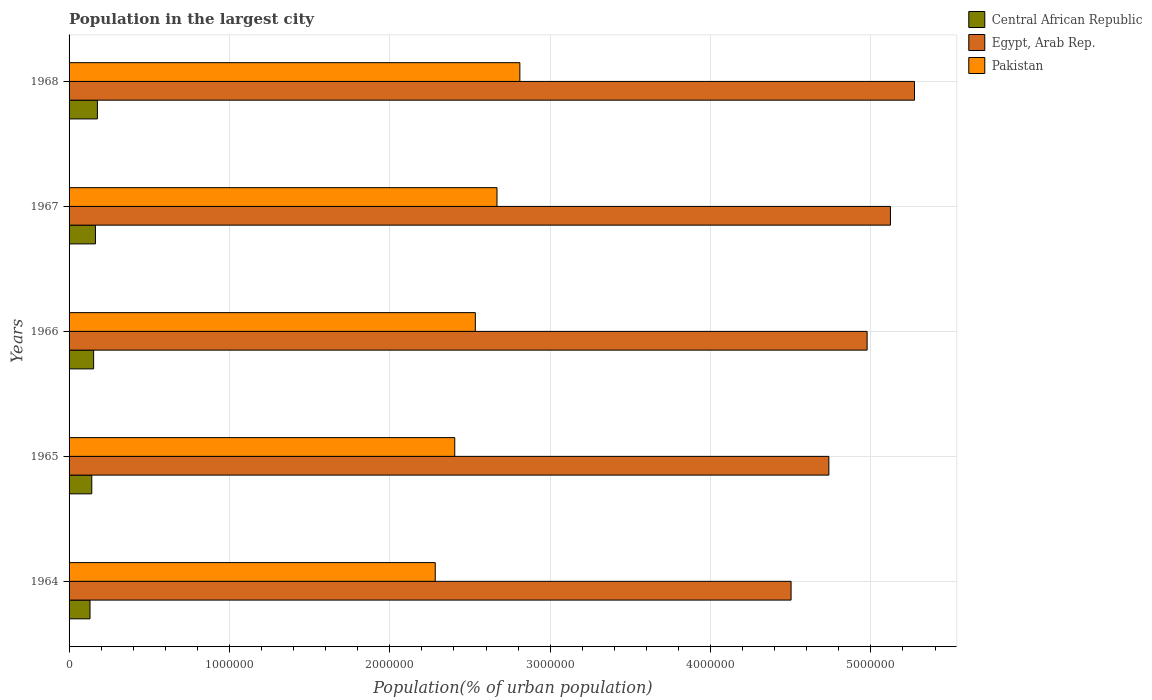How many different coloured bars are there?
Your answer should be compact. 3. Are the number of bars per tick equal to the number of legend labels?
Provide a short and direct response. Yes. How many bars are there on the 5th tick from the top?
Make the answer very short. 3. What is the label of the 3rd group of bars from the top?
Your response must be concise. 1966. What is the population in the largest city in Egypt, Arab Rep. in 1968?
Offer a terse response. 5.27e+06. Across all years, what is the maximum population in the largest city in Egypt, Arab Rep.?
Offer a very short reply. 5.27e+06. Across all years, what is the minimum population in the largest city in Central African Republic?
Offer a very short reply. 1.31e+05. In which year was the population in the largest city in Pakistan maximum?
Offer a terse response. 1968. In which year was the population in the largest city in Central African Republic minimum?
Give a very brief answer. 1964. What is the total population in the largest city in Pakistan in the graph?
Your answer should be very brief. 1.27e+07. What is the difference between the population in the largest city in Central African Republic in 1964 and that in 1965?
Offer a very short reply. -1.10e+04. What is the difference between the population in the largest city in Central African Republic in 1966 and the population in the largest city in Egypt, Arab Rep. in 1968?
Give a very brief answer. -5.12e+06. What is the average population in the largest city in Egypt, Arab Rep. per year?
Give a very brief answer. 4.92e+06. In the year 1967, what is the difference between the population in the largest city in Pakistan and population in the largest city in Egypt, Arab Rep.?
Keep it short and to the point. -2.45e+06. In how many years, is the population in the largest city in Central African Republic greater than 1200000 %?
Keep it short and to the point. 0. What is the ratio of the population in the largest city in Pakistan in 1966 to that in 1967?
Your answer should be compact. 0.95. Is the population in the largest city in Pakistan in 1966 less than that in 1967?
Keep it short and to the point. Yes. What is the difference between the highest and the second highest population in the largest city in Pakistan?
Keep it short and to the point. 1.43e+05. What is the difference between the highest and the lowest population in the largest city in Pakistan?
Ensure brevity in your answer.  5.28e+05. Is the sum of the population in the largest city in Pakistan in 1964 and 1966 greater than the maximum population in the largest city in Central African Republic across all years?
Keep it short and to the point. Yes. What does the 2nd bar from the top in 1964 represents?
Your answer should be compact. Egypt, Arab Rep. What does the 2nd bar from the bottom in 1966 represents?
Give a very brief answer. Egypt, Arab Rep. How many bars are there?
Offer a terse response. 15. Are all the bars in the graph horizontal?
Provide a short and direct response. Yes. What is the difference between two consecutive major ticks on the X-axis?
Make the answer very short. 1.00e+06. Are the values on the major ticks of X-axis written in scientific E-notation?
Offer a terse response. No. Does the graph contain any zero values?
Offer a very short reply. No. Where does the legend appear in the graph?
Make the answer very short. Top right. How many legend labels are there?
Keep it short and to the point. 3. What is the title of the graph?
Give a very brief answer. Population in the largest city. What is the label or title of the X-axis?
Make the answer very short. Population(% of urban population). What is the Population(% of urban population) in Central African Republic in 1964?
Provide a succinct answer. 1.31e+05. What is the Population(% of urban population) of Egypt, Arab Rep. in 1964?
Ensure brevity in your answer.  4.50e+06. What is the Population(% of urban population) in Pakistan in 1964?
Give a very brief answer. 2.28e+06. What is the Population(% of urban population) of Central African Republic in 1965?
Your answer should be very brief. 1.42e+05. What is the Population(% of urban population) in Egypt, Arab Rep. in 1965?
Ensure brevity in your answer.  4.74e+06. What is the Population(% of urban population) of Pakistan in 1965?
Your response must be concise. 2.41e+06. What is the Population(% of urban population) in Central African Republic in 1966?
Your answer should be compact. 1.53e+05. What is the Population(% of urban population) in Egypt, Arab Rep. in 1966?
Keep it short and to the point. 4.98e+06. What is the Population(% of urban population) in Pakistan in 1966?
Provide a short and direct response. 2.53e+06. What is the Population(% of urban population) of Central African Republic in 1967?
Give a very brief answer. 1.65e+05. What is the Population(% of urban population) of Egypt, Arab Rep. in 1967?
Make the answer very short. 5.12e+06. What is the Population(% of urban population) in Pakistan in 1967?
Provide a short and direct response. 2.67e+06. What is the Population(% of urban population) in Central African Republic in 1968?
Offer a terse response. 1.77e+05. What is the Population(% of urban population) of Egypt, Arab Rep. in 1968?
Make the answer very short. 5.27e+06. What is the Population(% of urban population) of Pakistan in 1968?
Your response must be concise. 2.81e+06. Across all years, what is the maximum Population(% of urban population) of Central African Republic?
Your answer should be compact. 1.77e+05. Across all years, what is the maximum Population(% of urban population) in Egypt, Arab Rep.?
Provide a succinct answer. 5.27e+06. Across all years, what is the maximum Population(% of urban population) of Pakistan?
Give a very brief answer. 2.81e+06. Across all years, what is the minimum Population(% of urban population) in Central African Republic?
Your answer should be compact. 1.31e+05. Across all years, what is the minimum Population(% of urban population) in Egypt, Arab Rep.?
Make the answer very short. 4.50e+06. Across all years, what is the minimum Population(% of urban population) in Pakistan?
Ensure brevity in your answer.  2.28e+06. What is the total Population(% of urban population) in Central African Republic in the graph?
Offer a very short reply. 7.67e+05. What is the total Population(% of urban population) of Egypt, Arab Rep. in the graph?
Keep it short and to the point. 2.46e+07. What is the total Population(% of urban population) of Pakistan in the graph?
Ensure brevity in your answer.  1.27e+07. What is the difference between the Population(% of urban population) of Central African Republic in 1964 and that in 1965?
Your answer should be compact. -1.10e+04. What is the difference between the Population(% of urban population) in Egypt, Arab Rep. in 1964 and that in 1965?
Your answer should be compact. -2.36e+05. What is the difference between the Population(% of urban population) of Pakistan in 1964 and that in 1965?
Your answer should be compact. -1.22e+05. What is the difference between the Population(% of urban population) in Central African Republic in 1964 and that in 1966?
Make the answer very short. -2.26e+04. What is the difference between the Population(% of urban population) of Egypt, Arab Rep. in 1964 and that in 1966?
Your answer should be compact. -4.74e+05. What is the difference between the Population(% of urban population) of Pakistan in 1964 and that in 1966?
Ensure brevity in your answer.  -2.50e+05. What is the difference between the Population(% of urban population) in Central African Republic in 1964 and that in 1967?
Your answer should be compact. -3.39e+04. What is the difference between the Population(% of urban population) of Egypt, Arab Rep. in 1964 and that in 1967?
Your answer should be very brief. -6.20e+05. What is the difference between the Population(% of urban population) of Pakistan in 1964 and that in 1967?
Give a very brief answer. -3.85e+05. What is the difference between the Population(% of urban population) of Central African Republic in 1964 and that in 1968?
Offer a very short reply. -4.61e+04. What is the difference between the Population(% of urban population) in Egypt, Arab Rep. in 1964 and that in 1968?
Provide a short and direct response. -7.70e+05. What is the difference between the Population(% of urban population) of Pakistan in 1964 and that in 1968?
Ensure brevity in your answer.  -5.28e+05. What is the difference between the Population(% of urban population) of Central African Republic in 1965 and that in 1966?
Offer a very short reply. -1.15e+04. What is the difference between the Population(% of urban population) of Egypt, Arab Rep. in 1965 and that in 1966?
Offer a terse response. -2.39e+05. What is the difference between the Population(% of urban population) of Pakistan in 1965 and that in 1966?
Your answer should be very brief. -1.28e+05. What is the difference between the Population(% of urban population) of Central African Republic in 1965 and that in 1967?
Offer a terse response. -2.29e+04. What is the difference between the Population(% of urban population) in Egypt, Arab Rep. in 1965 and that in 1967?
Provide a short and direct response. -3.84e+05. What is the difference between the Population(% of urban population) of Pakistan in 1965 and that in 1967?
Your answer should be very brief. -2.63e+05. What is the difference between the Population(% of urban population) of Central African Republic in 1965 and that in 1968?
Your response must be concise. -3.50e+04. What is the difference between the Population(% of urban population) in Egypt, Arab Rep. in 1965 and that in 1968?
Offer a very short reply. -5.34e+05. What is the difference between the Population(% of urban population) in Pakistan in 1965 and that in 1968?
Keep it short and to the point. -4.06e+05. What is the difference between the Population(% of urban population) in Central African Republic in 1966 and that in 1967?
Provide a short and direct response. -1.13e+04. What is the difference between the Population(% of urban population) of Egypt, Arab Rep. in 1966 and that in 1967?
Your answer should be compact. -1.45e+05. What is the difference between the Population(% of urban population) of Pakistan in 1966 and that in 1967?
Keep it short and to the point. -1.35e+05. What is the difference between the Population(% of urban population) in Central African Republic in 1966 and that in 1968?
Ensure brevity in your answer.  -2.35e+04. What is the difference between the Population(% of urban population) of Egypt, Arab Rep. in 1966 and that in 1968?
Your answer should be very brief. -2.95e+05. What is the difference between the Population(% of urban population) in Pakistan in 1966 and that in 1968?
Keep it short and to the point. -2.78e+05. What is the difference between the Population(% of urban population) in Central African Republic in 1967 and that in 1968?
Give a very brief answer. -1.22e+04. What is the difference between the Population(% of urban population) of Egypt, Arab Rep. in 1967 and that in 1968?
Ensure brevity in your answer.  -1.50e+05. What is the difference between the Population(% of urban population) in Pakistan in 1967 and that in 1968?
Give a very brief answer. -1.43e+05. What is the difference between the Population(% of urban population) of Central African Republic in 1964 and the Population(% of urban population) of Egypt, Arab Rep. in 1965?
Keep it short and to the point. -4.61e+06. What is the difference between the Population(% of urban population) of Central African Republic in 1964 and the Population(% of urban population) of Pakistan in 1965?
Offer a very short reply. -2.27e+06. What is the difference between the Population(% of urban population) in Egypt, Arab Rep. in 1964 and the Population(% of urban population) in Pakistan in 1965?
Offer a terse response. 2.10e+06. What is the difference between the Population(% of urban population) of Central African Republic in 1964 and the Population(% of urban population) of Egypt, Arab Rep. in 1966?
Provide a succinct answer. -4.85e+06. What is the difference between the Population(% of urban population) in Central African Republic in 1964 and the Population(% of urban population) in Pakistan in 1966?
Your response must be concise. -2.40e+06. What is the difference between the Population(% of urban population) in Egypt, Arab Rep. in 1964 and the Population(% of urban population) in Pakistan in 1966?
Provide a succinct answer. 1.97e+06. What is the difference between the Population(% of urban population) of Central African Republic in 1964 and the Population(% of urban population) of Egypt, Arab Rep. in 1967?
Your response must be concise. -4.99e+06. What is the difference between the Population(% of urban population) in Central African Republic in 1964 and the Population(% of urban population) in Pakistan in 1967?
Keep it short and to the point. -2.54e+06. What is the difference between the Population(% of urban population) of Egypt, Arab Rep. in 1964 and the Population(% of urban population) of Pakistan in 1967?
Give a very brief answer. 1.83e+06. What is the difference between the Population(% of urban population) in Central African Republic in 1964 and the Population(% of urban population) in Egypt, Arab Rep. in 1968?
Keep it short and to the point. -5.14e+06. What is the difference between the Population(% of urban population) in Central African Republic in 1964 and the Population(% of urban population) in Pakistan in 1968?
Offer a terse response. -2.68e+06. What is the difference between the Population(% of urban population) of Egypt, Arab Rep. in 1964 and the Population(% of urban population) of Pakistan in 1968?
Your answer should be compact. 1.69e+06. What is the difference between the Population(% of urban population) in Central African Republic in 1965 and the Population(% of urban population) in Egypt, Arab Rep. in 1966?
Make the answer very short. -4.83e+06. What is the difference between the Population(% of urban population) in Central African Republic in 1965 and the Population(% of urban population) in Pakistan in 1966?
Your answer should be compact. -2.39e+06. What is the difference between the Population(% of urban population) in Egypt, Arab Rep. in 1965 and the Population(% of urban population) in Pakistan in 1966?
Offer a very short reply. 2.20e+06. What is the difference between the Population(% of urban population) of Central African Republic in 1965 and the Population(% of urban population) of Egypt, Arab Rep. in 1967?
Your response must be concise. -4.98e+06. What is the difference between the Population(% of urban population) in Central African Republic in 1965 and the Population(% of urban population) in Pakistan in 1967?
Keep it short and to the point. -2.53e+06. What is the difference between the Population(% of urban population) in Egypt, Arab Rep. in 1965 and the Population(% of urban population) in Pakistan in 1967?
Offer a terse response. 2.07e+06. What is the difference between the Population(% of urban population) of Central African Republic in 1965 and the Population(% of urban population) of Egypt, Arab Rep. in 1968?
Provide a succinct answer. -5.13e+06. What is the difference between the Population(% of urban population) in Central African Republic in 1965 and the Population(% of urban population) in Pakistan in 1968?
Make the answer very short. -2.67e+06. What is the difference between the Population(% of urban population) in Egypt, Arab Rep. in 1965 and the Population(% of urban population) in Pakistan in 1968?
Your answer should be compact. 1.93e+06. What is the difference between the Population(% of urban population) in Central African Republic in 1966 and the Population(% of urban population) in Egypt, Arab Rep. in 1967?
Your response must be concise. -4.97e+06. What is the difference between the Population(% of urban population) of Central African Republic in 1966 and the Population(% of urban population) of Pakistan in 1967?
Provide a succinct answer. -2.52e+06. What is the difference between the Population(% of urban population) of Egypt, Arab Rep. in 1966 and the Population(% of urban population) of Pakistan in 1967?
Make the answer very short. 2.31e+06. What is the difference between the Population(% of urban population) of Central African Republic in 1966 and the Population(% of urban population) of Egypt, Arab Rep. in 1968?
Your answer should be compact. -5.12e+06. What is the difference between the Population(% of urban population) in Central African Republic in 1966 and the Population(% of urban population) in Pakistan in 1968?
Offer a very short reply. -2.66e+06. What is the difference between the Population(% of urban population) in Egypt, Arab Rep. in 1966 and the Population(% of urban population) in Pakistan in 1968?
Keep it short and to the point. 2.17e+06. What is the difference between the Population(% of urban population) of Central African Republic in 1967 and the Population(% of urban population) of Egypt, Arab Rep. in 1968?
Make the answer very short. -5.11e+06. What is the difference between the Population(% of urban population) in Central African Republic in 1967 and the Population(% of urban population) in Pakistan in 1968?
Provide a succinct answer. -2.65e+06. What is the difference between the Population(% of urban population) of Egypt, Arab Rep. in 1967 and the Population(% of urban population) of Pakistan in 1968?
Provide a succinct answer. 2.31e+06. What is the average Population(% of urban population) of Central African Republic per year?
Make the answer very short. 1.53e+05. What is the average Population(% of urban population) in Egypt, Arab Rep. per year?
Give a very brief answer. 4.92e+06. What is the average Population(% of urban population) of Pakistan per year?
Your answer should be compact. 2.54e+06. In the year 1964, what is the difference between the Population(% of urban population) of Central African Republic and Population(% of urban population) of Egypt, Arab Rep.?
Give a very brief answer. -4.37e+06. In the year 1964, what is the difference between the Population(% of urban population) of Central African Republic and Population(% of urban population) of Pakistan?
Ensure brevity in your answer.  -2.15e+06. In the year 1964, what is the difference between the Population(% of urban population) in Egypt, Arab Rep. and Population(% of urban population) in Pakistan?
Your response must be concise. 2.22e+06. In the year 1965, what is the difference between the Population(% of urban population) of Central African Republic and Population(% of urban population) of Egypt, Arab Rep.?
Offer a terse response. -4.60e+06. In the year 1965, what is the difference between the Population(% of urban population) in Central African Republic and Population(% of urban population) in Pakistan?
Offer a very short reply. -2.26e+06. In the year 1965, what is the difference between the Population(% of urban population) of Egypt, Arab Rep. and Population(% of urban population) of Pakistan?
Your answer should be compact. 2.33e+06. In the year 1966, what is the difference between the Population(% of urban population) of Central African Republic and Population(% of urban population) of Egypt, Arab Rep.?
Your answer should be compact. -4.82e+06. In the year 1966, what is the difference between the Population(% of urban population) in Central African Republic and Population(% of urban population) in Pakistan?
Give a very brief answer. -2.38e+06. In the year 1966, what is the difference between the Population(% of urban population) of Egypt, Arab Rep. and Population(% of urban population) of Pakistan?
Offer a very short reply. 2.44e+06. In the year 1967, what is the difference between the Population(% of urban population) in Central African Republic and Population(% of urban population) in Egypt, Arab Rep.?
Provide a short and direct response. -4.96e+06. In the year 1967, what is the difference between the Population(% of urban population) in Central African Republic and Population(% of urban population) in Pakistan?
Your answer should be compact. -2.50e+06. In the year 1967, what is the difference between the Population(% of urban population) in Egypt, Arab Rep. and Population(% of urban population) in Pakistan?
Your response must be concise. 2.45e+06. In the year 1968, what is the difference between the Population(% of urban population) in Central African Republic and Population(% of urban population) in Egypt, Arab Rep.?
Offer a terse response. -5.10e+06. In the year 1968, what is the difference between the Population(% of urban population) in Central African Republic and Population(% of urban population) in Pakistan?
Give a very brief answer. -2.63e+06. In the year 1968, what is the difference between the Population(% of urban population) of Egypt, Arab Rep. and Population(% of urban population) of Pakistan?
Your answer should be compact. 2.46e+06. What is the ratio of the Population(% of urban population) in Central African Republic in 1964 to that in 1965?
Offer a very short reply. 0.92. What is the ratio of the Population(% of urban population) of Egypt, Arab Rep. in 1964 to that in 1965?
Provide a succinct answer. 0.95. What is the ratio of the Population(% of urban population) in Pakistan in 1964 to that in 1965?
Your response must be concise. 0.95. What is the ratio of the Population(% of urban population) in Central African Republic in 1964 to that in 1966?
Give a very brief answer. 0.85. What is the ratio of the Population(% of urban population) of Egypt, Arab Rep. in 1964 to that in 1966?
Your response must be concise. 0.9. What is the ratio of the Population(% of urban population) in Pakistan in 1964 to that in 1966?
Ensure brevity in your answer.  0.9. What is the ratio of the Population(% of urban population) of Central African Republic in 1964 to that in 1967?
Give a very brief answer. 0.79. What is the ratio of the Population(% of urban population) in Egypt, Arab Rep. in 1964 to that in 1967?
Provide a succinct answer. 0.88. What is the ratio of the Population(% of urban population) of Pakistan in 1964 to that in 1967?
Provide a succinct answer. 0.86. What is the ratio of the Population(% of urban population) in Central African Republic in 1964 to that in 1968?
Provide a succinct answer. 0.74. What is the ratio of the Population(% of urban population) of Egypt, Arab Rep. in 1964 to that in 1968?
Keep it short and to the point. 0.85. What is the ratio of the Population(% of urban population) of Pakistan in 1964 to that in 1968?
Your response must be concise. 0.81. What is the ratio of the Population(% of urban population) in Central African Republic in 1965 to that in 1966?
Your response must be concise. 0.92. What is the ratio of the Population(% of urban population) in Egypt, Arab Rep. in 1965 to that in 1966?
Provide a succinct answer. 0.95. What is the ratio of the Population(% of urban population) of Pakistan in 1965 to that in 1966?
Offer a terse response. 0.95. What is the ratio of the Population(% of urban population) in Central African Republic in 1965 to that in 1967?
Your answer should be compact. 0.86. What is the ratio of the Population(% of urban population) of Egypt, Arab Rep. in 1965 to that in 1967?
Give a very brief answer. 0.93. What is the ratio of the Population(% of urban population) of Pakistan in 1965 to that in 1967?
Ensure brevity in your answer.  0.9. What is the ratio of the Population(% of urban population) of Central African Republic in 1965 to that in 1968?
Provide a succinct answer. 0.8. What is the ratio of the Population(% of urban population) in Egypt, Arab Rep. in 1965 to that in 1968?
Offer a very short reply. 0.9. What is the ratio of the Population(% of urban population) in Pakistan in 1965 to that in 1968?
Your answer should be very brief. 0.86. What is the ratio of the Population(% of urban population) in Central African Republic in 1966 to that in 1967?
Ensure brevity in your answer.  0.93. What is the ratio of the Population(% of urban population) in Egypt, Arab Rep. in 1966 to that in 1967?
Ensure brevity in your answer.  0.97. What is the ratio of the Population(% of urban population) in Pakistan in 1966 to that in 1967?
Offer a terse response. 0.95. What is the ratio of the Population(% of urban population) of Central African Republic in 1966 to that in 1968?
Give a very brief answer. 0.87. What is the ratio of the Population(% of urban population) of Egypt, Arab Rep. in 1966 to that in 1968?
Provide a succinct answer. 0.94. What is the ratio of the Population(% of urban population) of Pakistan in 1966 to that in 1968?
Your response must be concise. 0.9. What is the ratio of the Population(% of urban population) of Central African Republic in 1967 to that in 1968?
Make the answer very short. 0.93. What is the ratio of the Population(% of urban population) in Egypt, Arab Rep. in 1967 to that in 1968?
Keep it short and to the point. 0.97. What is the ratio of the Population(% of urban population) in Pakistan in 1967 to that in 1968?
Give a very brief answer. 0.95. What is the difference between the highest and the second highest Population(% of urban population) in Central African Republic?
Your response must be concise. 1.22e+04. What is the difference between the highest and the second highest Population(% of urban population) of Egypt, Arab Rep.?
Your answer should be very brief. 1.50e+05. What is the difference between the highest and the second highest Population(% of urban population) in Pakistan?
Your response must be concise. 1.43e+05. What is the difference between the highest and the lowest Population(% of urban population) of Central African Republic?
Your response must be concise. 4.61e+04. What is the difference between the highest and the lowest Population(% of urban population) in Egypt, Arab Rep.?
Provide a succinct answer. 7.70e+05. What is the difference between the highest and the lowest Population(% of urban population) in Pakistan?
Keep it short and to the point. 5.28e+05. 